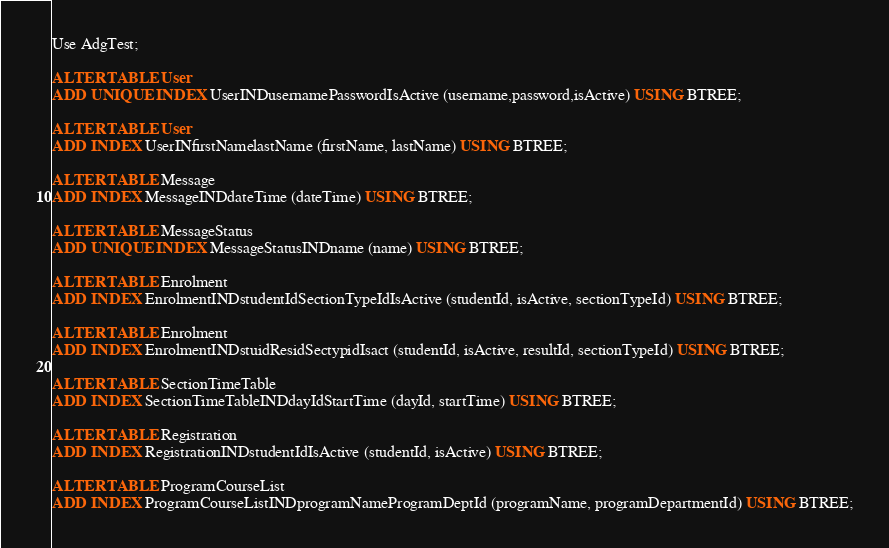Convert code to text. <code><loc_0><loc_0><loc_500><loc_500><_SQL_>Use AdgTest;

ALTER TABLE User
ADD UNIQUE INDEX UserINDusernamePasswordIsActive (username,password,isActive) USING BTREE;

ALTER TABLE User
ADD INDEX UserINfirstNamelastName (firstName, lastName) USING BTREE;

ALTER TABLE Message
ADD INDEX MessageINDdateTime (dateTime) USING BTREE;

ALTER TABLE MessageStatus
ADD UNIQUE INDEX MessageStatusINDname (name) USING BTREE;

ALTER TABLE Enrolment
ADD INDEX EnrolmentINDstudentIdSectionTypeIdIsActive (studentId, isActive, sectionTypeId) USING BTREE;

ALTER TABLE Enrolment
ADD INDEX EnrolmentINDstuidResidSectypidIsact (studentId, isActive, resultId, sectionTypeId) USING BTREE;

ALTER TABLE SectionTimeTable
ADD INDEX SectionTimeTableINDdayIdStartTime (dayId, startTime) USING BTREE;

ALTER TABLE Registration
ADD INDEX RegistrationINDstudentIdIsActive (studentId, isActive) USING BTREE;

ALTER TABLE ProgramCourseList
ADD INDEX ProgramCourseListINDprogramNameProgramDeptId (programName, programDepartmentId) USING BTREE;





</code> 